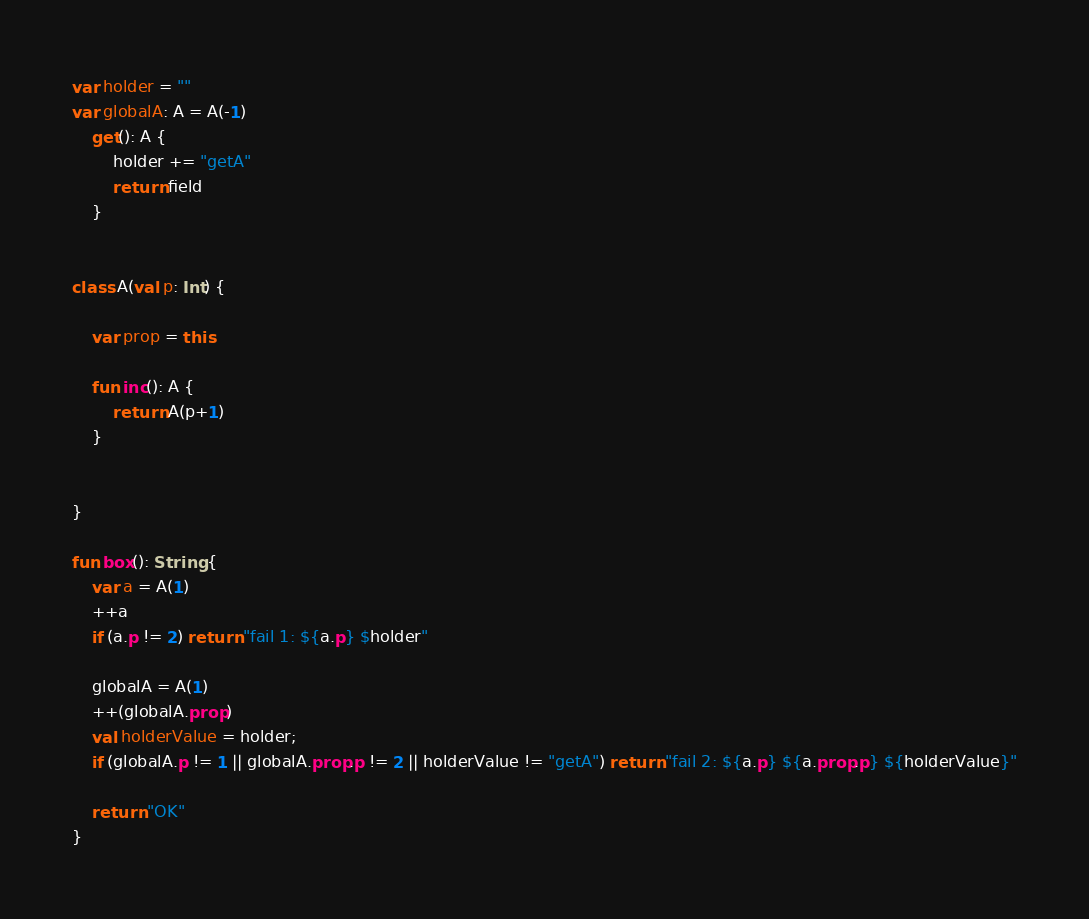Convert code to text. <code><loc_0><loc_0><loc_500><loc_500><_Kotlin_>var holder = ""
var globalA: A = A(-1)
    get(): A {
        holder += "getA"
        return field
    }


class A(val p: Int) {

    var prop = this

    fun inc(): A {
        return A(p+1)
    }


}

fun box(): String {
    var a = A(1)
    ++a
    if (a.p != 2) return "fail 1: ${a.p} $holder"

    globalA = A(1)
    ++(globalA.prop)
    val holderValue = holder;
    if (globalA.p != 1 || globalA.prop.p != 2 || holderValue != "getA") return "fail 2: ${a.p} ${a.prop.p} ${holderValue}"

    return "OK"
}</code> 